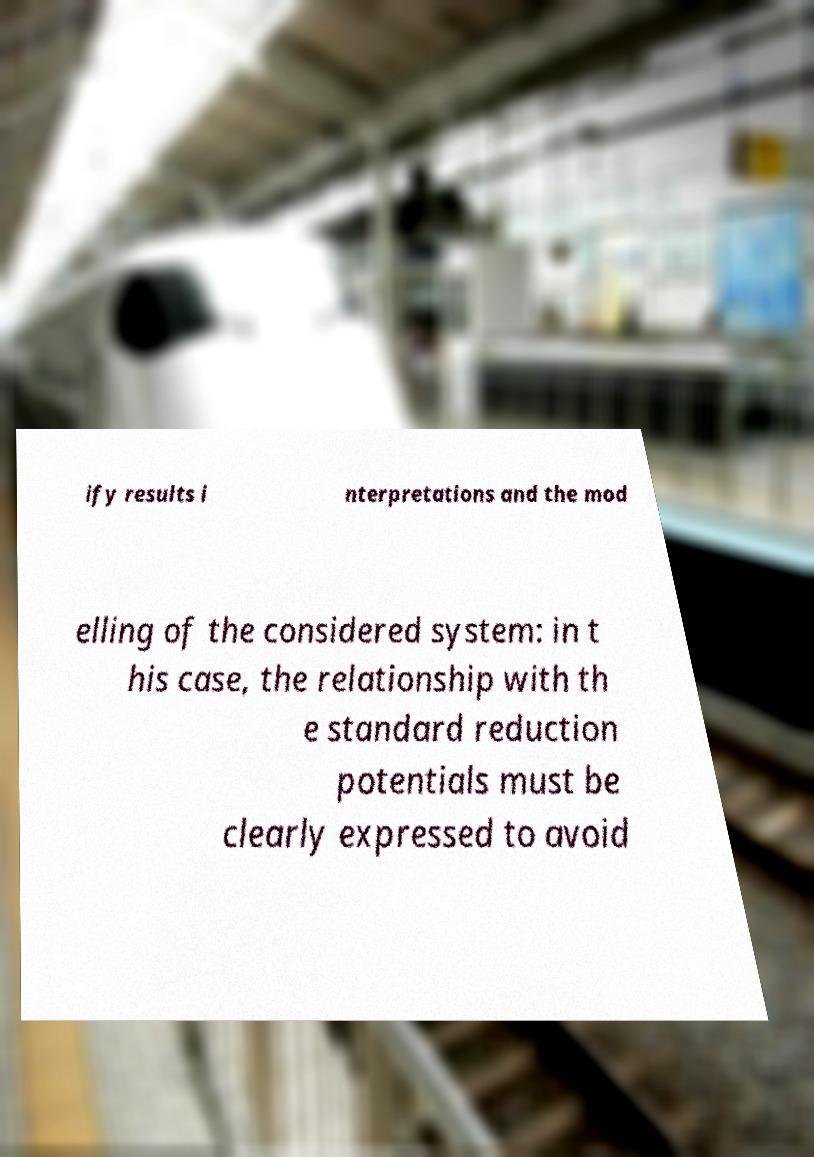For documentation purposes, I need the text within this image transcribed. Could you provide that? ify results i nterpretations and the mod elling of the considered system: in t his case, the relationship with th e standard reduction potentials must be clearly expressed to avoid 